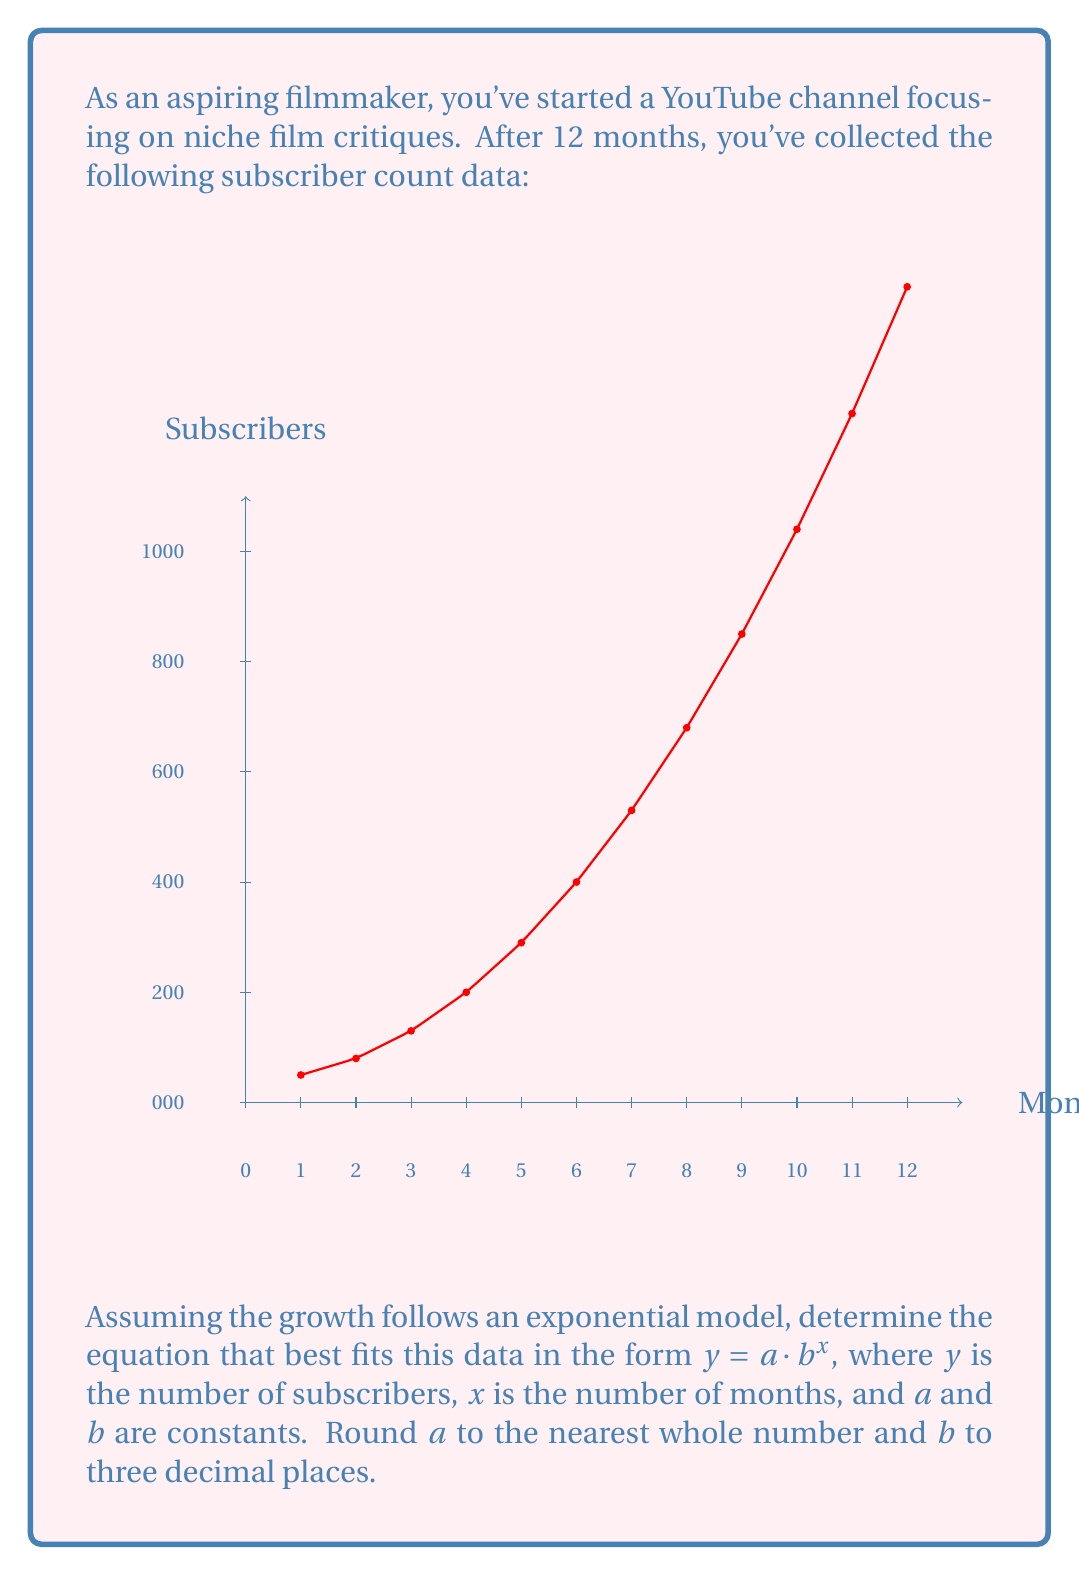Give your solution to this math problem. To find the exponential model $y = a \cdot b^x$ that best fits the data, we'll use the exponential regression method:

1) First, we'll transform the data by taking the natural log of y-values:
   $\ln(y) = \ln(a \cdot b^x) = \ln(a) + x\ln(b)$

2) Let $Y = \ln(y)$, $A = \ln(a)$, and $B = \ln(b)$. Now we have a linear equation:
   $Y = A + Bx$

3) We can use linear regression to find A and B. The formulas are:
   $B = \frac{n\sum(xY) - \sum x \sum Y}{n\sum x^2 - (\sum x)^2}$
   $A = \bar{Y} - B\bar{x}$

4) Calculate the necessary sums:
   $\sum x = 78$
   $\sum Y = 69.9058$
   $\sum xY = 480.8901$
   $\sum x^2 = 650$
   $n = 12$

5) Plug into the formulas:
   $B = \frac{12(480.8901) - 78(69.9058)}{12(650) - 78^2} = 0.3438$
   $A = \frac{69.9058}{12} - 0.3438 \cdot \frac{78}{12} = 3.7101$

6) Now we have $Y = 3.7101 + 0.3438x$

7) Transform back to get $y = e^{3.7101} \cdot (e^{0.3438})^x$

8) Therefore, $a = e^{3.7101} \approx 40.8573$ and $b = e^{0.3438} \approx 1.4103$

9) Rounding $a$ to the nearest whole number and $b$ to three decimal places:
   $a = 41$ and $b = 1.410$

Thus, the exponential model is $y = 41 \cdot 1.410^x$.
Answer: $y = 41 \cdot 1.410^x$ 